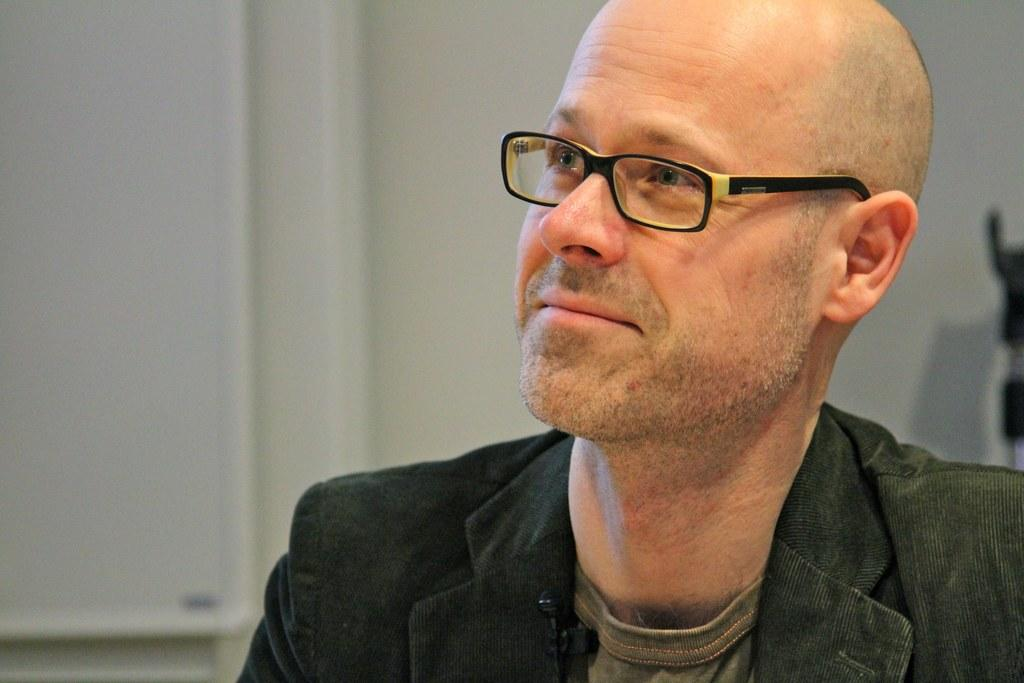Who or what is the main subject in the image? There is a person in the center of the image. What can be observed about the person's appearance? The person is wearing spectacles. What is visible in the background of the image? There is a wall in the background of the image. What type of kite is the person holding in the image? There is no kite present in the image; the person is wearing spectacles and standing in front of a wall. 